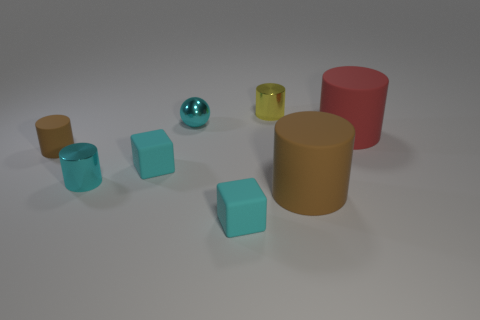What is the relative size of the objects to each other? The objects in the image vary in size. The cylinders are the tallest objects with the red one being the smallest in height. The largest object in terms of both height and volume is the tan cylinder. The turquoise cubes are medium-sized and uniform in shape and size, while the sphere is smaller than the cubes but larger than the smallest cylinder. 